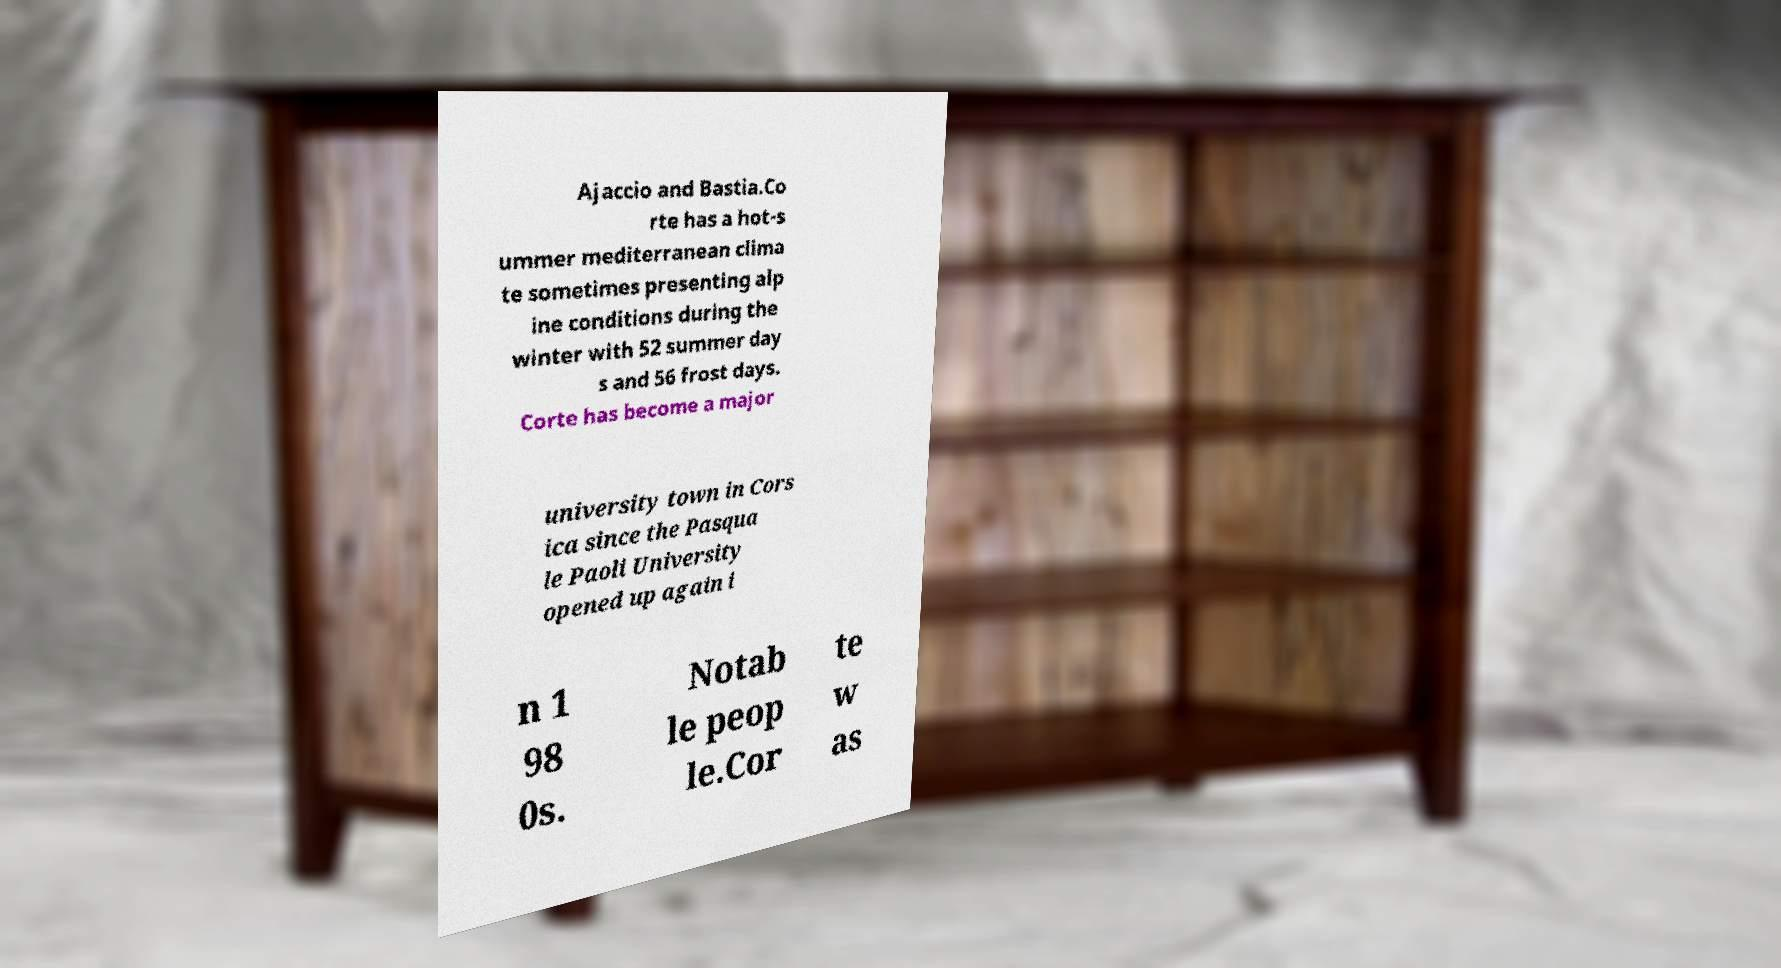Please read and relay the text visible in this image. What does it say? Ajaccio and Bastia.Co rte has a hot-s ummer mediterranean clima te sometimes presenting alp ine conditions during the winter with 52 summer day s and 56 frost days. Corte has become a major university town in Cors ica since the Pasqua le Paoli University opened up again i n 1 98 0s. Notab le peop le.Cor te w as 